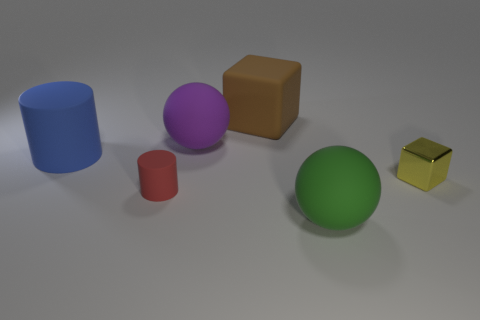Add 4 blue cylinders. How many objects exist? 10 Subtract 2 cubes. How many cubes are left? 0 Subtract all red cylinders. How many purple spheres are left? 1 Subtract all gray metallic blocks. Subtract all yellow metal objects. How many objects are left? 5 Add 4 rubber cubes. How many rubber cubes are left? 5 Add 4 big blue matte cylinders. How many big blue matte cylinders exist? 5 Subtract 1 yellow blocks. How many objects are left? 5 Subtract all cylinders. How many objects are left? 4 Subtract all purple spheres. Subtract all green cubes. How many spheres are left? 1 